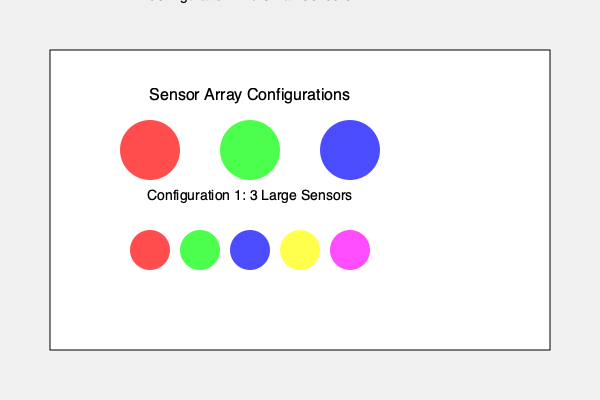Consider two sensor array configurations for an autonomous vehicle designed to collect field data in extreme weather conditions, as shown in the diagram. Configuration 1 uses three large sensors, while Configuration 2 employs five smaller sensors. Given that the probability of sensor failure in extreme conditions is 0.2 for large sensors and 0.1 for small sensors, calculate the probability that at least two sensors will remain functional in each configuration. Which configuration is more robust for data collection in extreme environments? To solve this problem, we need to calculate the probability of at least two sensors remaining functional for each configuration:

1. For Configuration 1 (3 large sensors):
   - Probability of a single sensor failing: $p = 0.2$
   - Probability of a single sensor functioning: $q = 1 - p = 0.8$
   - We need the probability of 2 or 3 sensors functioning
   - $P(\text{at least 2 functioning}) = \binom{3}{2}q^2p + \binom{3}{3}q^3$
   - $P(\text{at least 2 functioning}) = 3 \cdot 0.8^2 \cdot 0.2 + 1 \cdot 0.8^3$
   - $P(\text{at least 2 functioning}) = 0.384 + 0.512 = 0.896$

2. For Configuration 2 (5 small sensors):
   - Probability of a single sensor failing: $p = 0.1$
   - Probability of a single sensor functioning: $q = 1 - p = 0.9$
   - We need the probability of 2, 3, 4, or 5 sensors functioning
   - $P(\text{at least 2 functioning}) = \binom{5}{2}q^2p^3 + \binom{5}{3}q^3p^2 + \binom{5}{4}q^4p + \binom{5}{5}q^5$
   - $P(\text{at least 2 functioning}) = 10 \cdot 0.9^2 \cdot 0.1^3 + 10 \cdot 0.9^3 \cdot 0.1^2 + 5 \cdot 0.9^4 \cdot 0.1 + 1 \cdot 0.9^5$
   - $P(\text{at least 2 functioning}) = 0.0081 + 0.0729 + 0.2916 + 0.5905 = 0.9631$

Configuration 2 has a higher probability (0.9631) of at least two sensors remaining functional compared to Configuration 1 (0.896). Therefore, Configuration 2 is more robust for data collection in extreme environments.
Answer: Configuration 2 (5 small sensors) is more robust, with a 0.9631 probability of at least two functional sensors. 